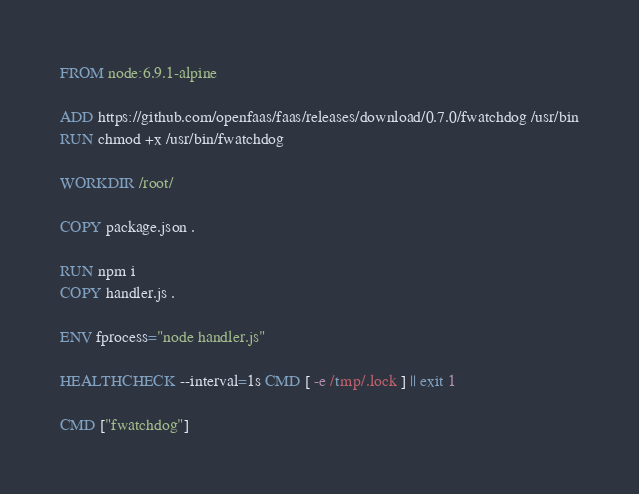<code> <loc_0><loc_0><loc_500><loc_500><_Dockerfile_>FROM node:6.9.1-alpine

ADD https://github.com/openfaas/faas/releases/download/0.7.0/fwatchdog /usr/bin
RUN chmod +x /usr/bin/fwatchdog

WORKDIR /root/

COPY package.json .

RUN npm i
COPY handler.js .

ENV fprocess="node handler.js"

HEALTHCHECK --interval=1s CMD [ -e /tmp/.lock ] || exit 1

CMD ["fwatchdog"]

</code> 